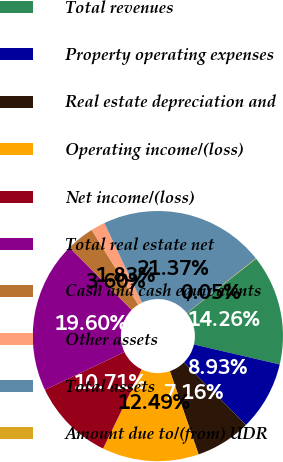Convert chart to OTSL. <chart><loc_0><loc_0><loc_500><loc_500><pie_chart><fcel>Total revenues<fcel>Property operating expenses<fcel>Real estate depreciation and<fcel>Operating income/(loss)<fcel>Net income/(loss)<fcel>Total real estate net<fcel>Cash and cash equivalents<fcel>Other assets<fcel>Total assets<fcel>Amount due to/(from) UDR<nl><fcel>14.26%<fcel>8.93%<fcel>7.16%<fcel>12.49%<fcel>10.71%<fcel>19.6%<fcel>3.6%<fcel>1.83%<fcel>21.37%<fcel>0.05%<nl></chart> 